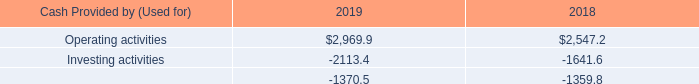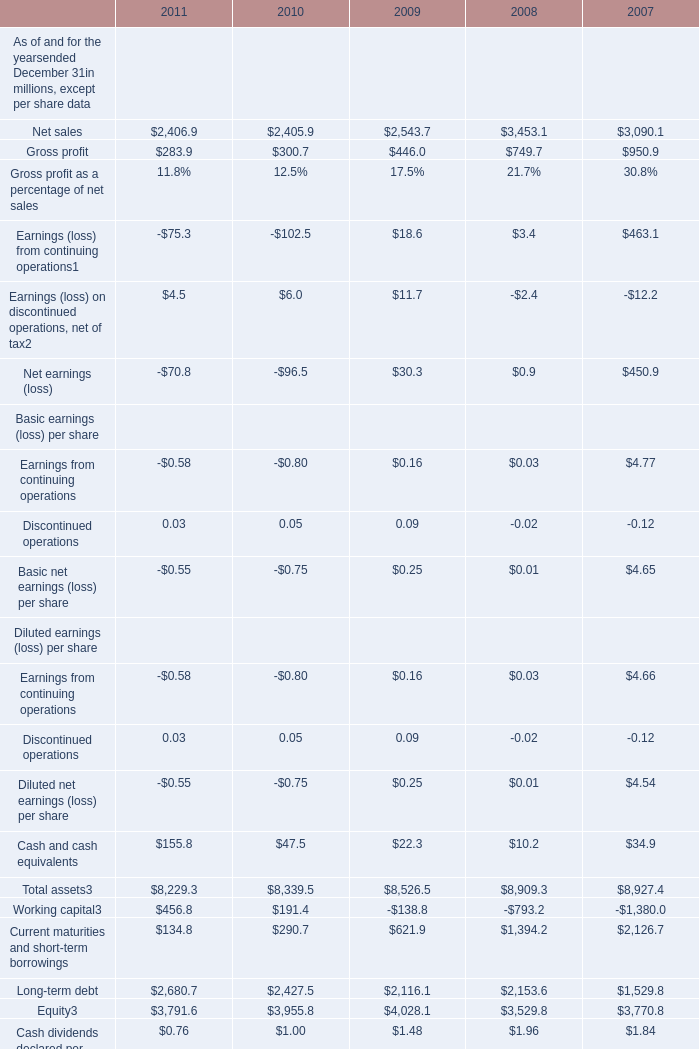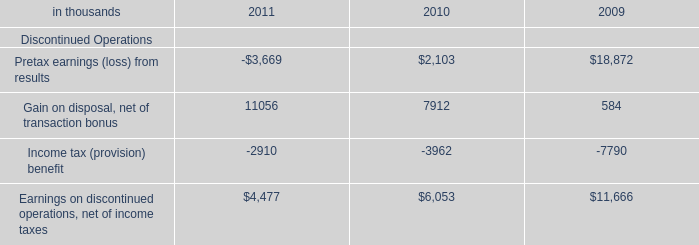What's the greatest value of Gross profit in 2011 and 2010? (in million) 
Computations: (283.9 + 300.7)
Answer: 584.6. 